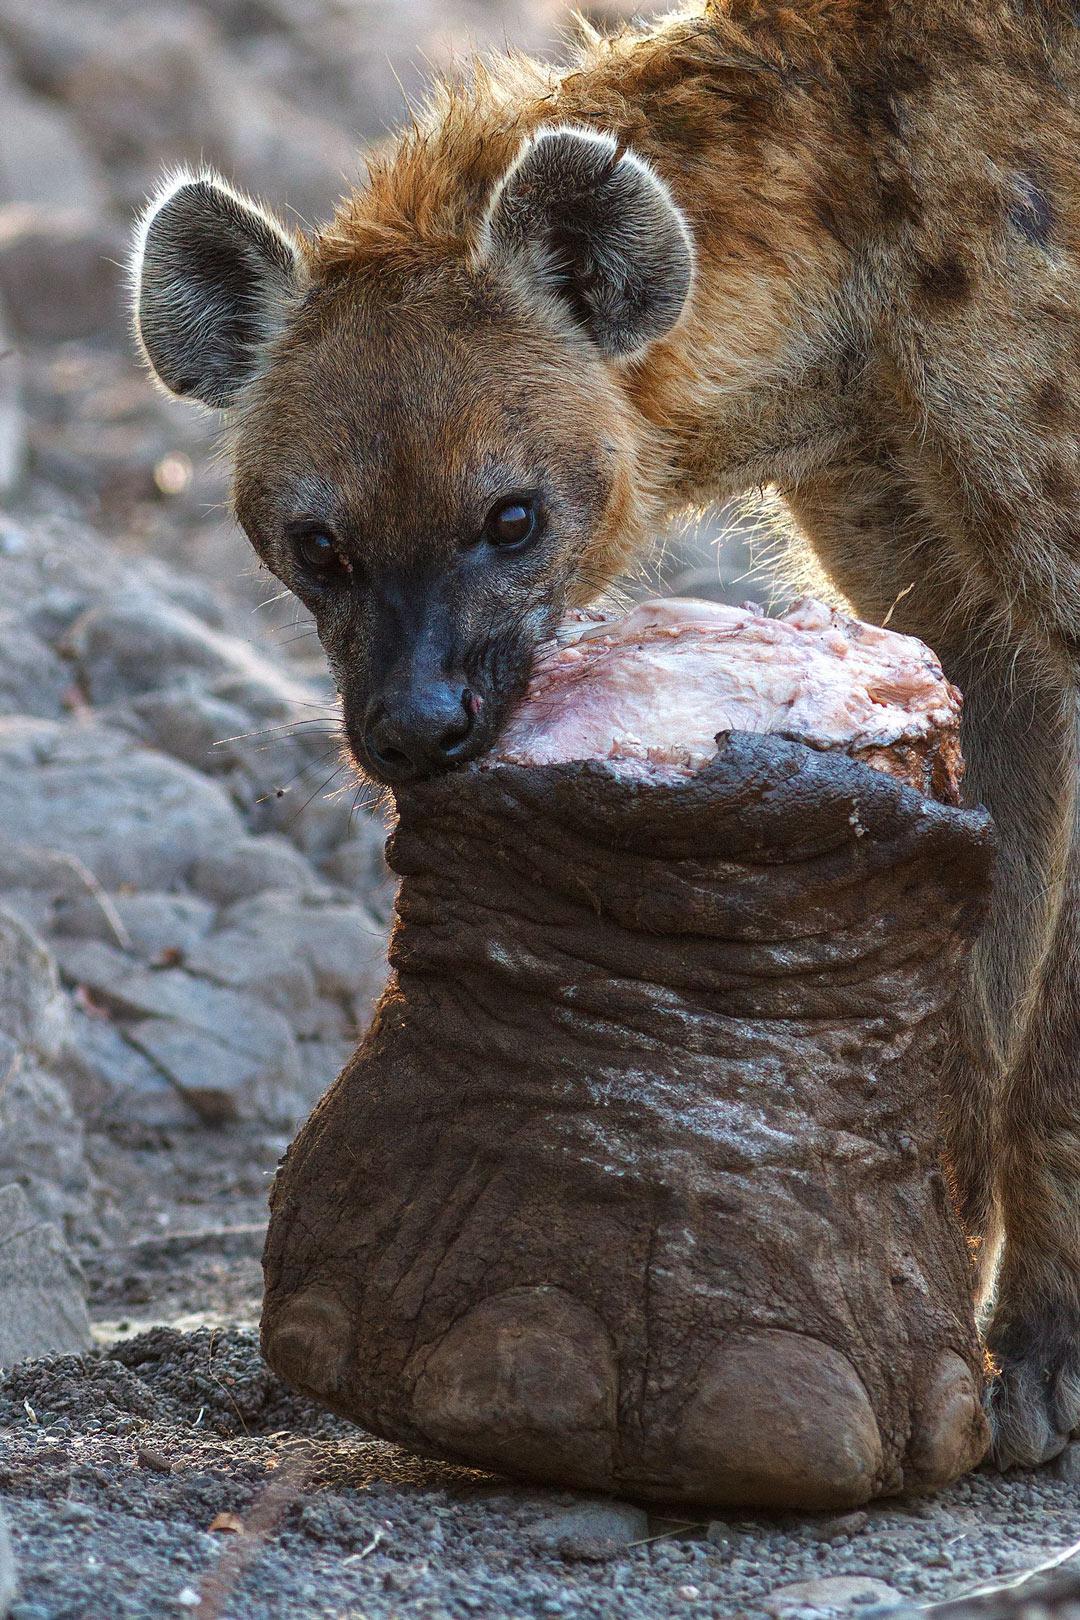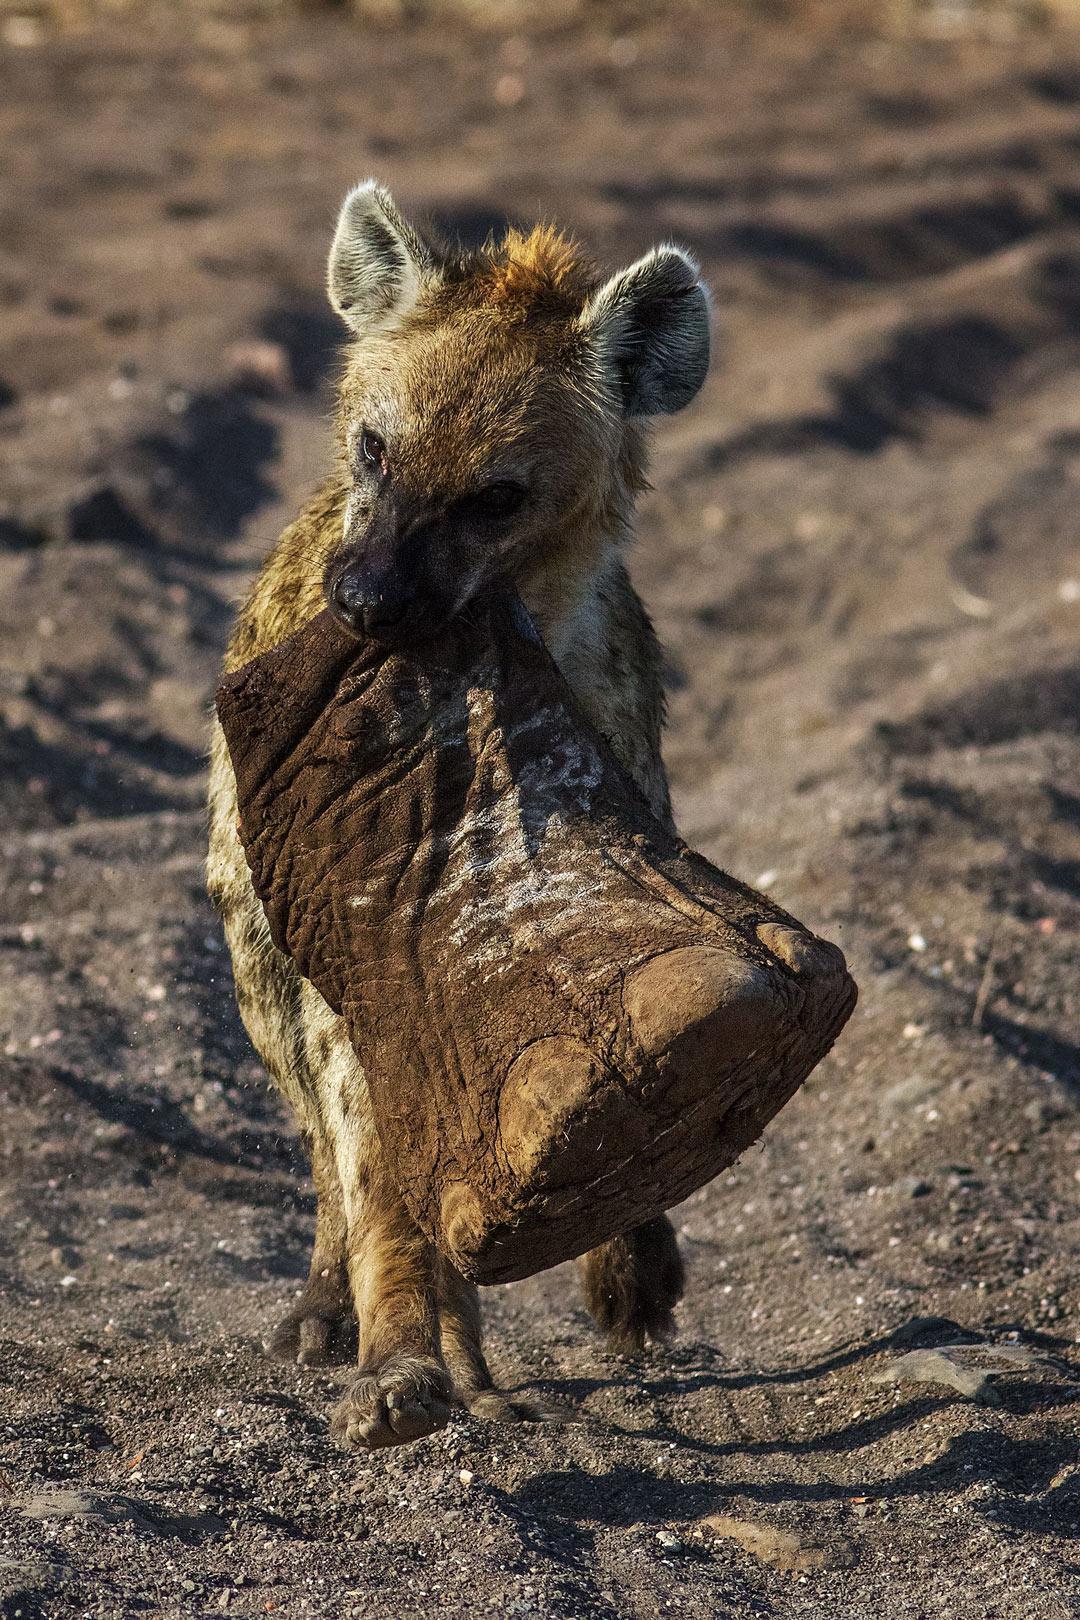The first image is the image on the left, the second image is the image on the right. Considering the images on both sides, is "The animal in the image on the right is carrying an elephant foot." valid? Answer yes or no. Yes. 